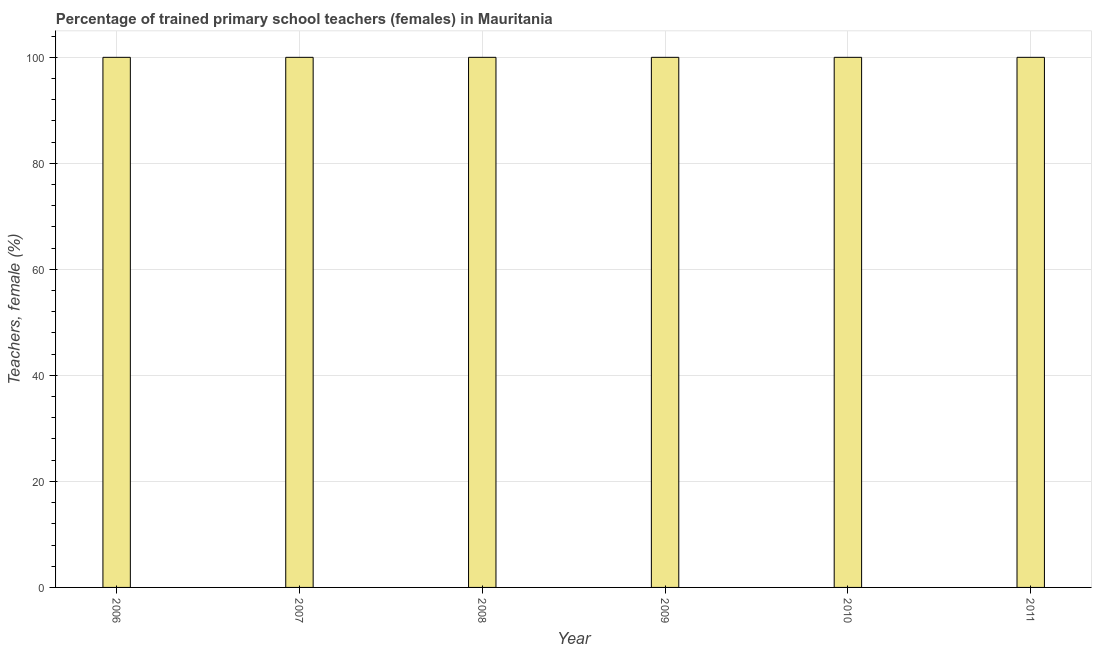Does the graph contain any zero values?
Give a very brief answer. No. Does the graph contain grids?
Your answer should be compact. Yes. What is the title of the graph?
Your response must be concise. Percentage of trained primary school teachers (females) in Mauritania. What is the label or title of the Y-axis?
Keep it short and to the point. Teachers, female (%). In which year was the percentage of trained female teachers minimum?
Make the answer very short. 2006. What is the sum of the percentage of trained female teachers?
Provide a succinct answer. 600. What is the median percentage of trained female teachers?
Give a very brief answer. 100. In how many years, is the percentage of trained female teachers greater than 32 %?
Your response must be concise. 6. Do a majority of the years between 2006 and 2011 (inclusive) have percentage of trained female teachers greater than 44 %?
Provide a succinct answer. Yes. What is the ratio of the percentage of trained female teachers in 2007 to that in 2011?
Provide a succinct answer. 1. What is the difference between the highest and the second highest percentage of trained female teachers?
Your response must be concise. 0. What is the difference between the highest and the lowest percentage of trained female teachers?
Ensure brevity in your answer.  0. How many bars are there?
Offer a terse response. 6. How many years are there in the graph?
Ensure brevity in your answer.  6. Are the values on the major ticks of Y-axis written in scientific E-notation?
Your response must be concise. No. What is the Teachers, female (%) in 2006?
Ensure brevity in your answer.  100. What is the Teachers, female (%) of 2011?
Offer a very short reply. 100. What is the difference between the Teachers, female (%) in 2006 and 2007?
Offer a terse response. 0. What is the difference between the Teachers, female (%) in 2006 and 2009?
Offer a very short reply. 0. What is the difference between the Teachers, female (%) in 2006 and 2010?
Your answer should be compact. 0. What is the difference between the Teachers, female (%) in 2006 and 2011?
Your answer should be very brief. 0. What is the difference between the Teachers, female (%) in 2008 and 2009?
Give a very brief answer. 0. What is the difference between the Teachers, female (%) in 2008 and 2010?
Offer a very short reply. 0. What is the difference between the Teachers, female (%) in 2009 and 2010?
Offer a terse response. 0. What is the difference between the Teachers, female (%) in 2009 and 2011?
Your answer should be very brief. 0. What is the ratio of the Teachers, female (%) in 2006 to that in 2007?
Provide a short and direct response. 1. What is the ratio of the Teachers, female (%) in 2006 to that in 2009?
Ensure brevity in your answer.  1. What is the ratio of the Teachers, female (%) in 2006 to that in 2010?
Give a very brief answer. 1. What is the ratio of the Teachers, female (%) in 2006 to that in 2011?
Offer a very short reply. 1. What is the ratio of the Teachers, female (%) in 2007 to that in 2008?
Provide a succinct answer. 1. What is the ratio of the Teachers, female (%) in 2007 to that in 2009?
Provide a succinct answer. 1. What is the ratio of the Teachers, female (%) in 2007 to that in 2010?
Provide a succinct answer. 1. What is the ratio of the Teachers, female (%) in 2008 to that in 2009?
Offer a terse response. 1. What is the ratio of the Teachers, female (%) in 2008 to that in 2011?
Ensure brevity in your answer.  1. What is the ratio of the Teachers, female (%) in 2009 to that in 2011?
Give a very brief answer. 1. 